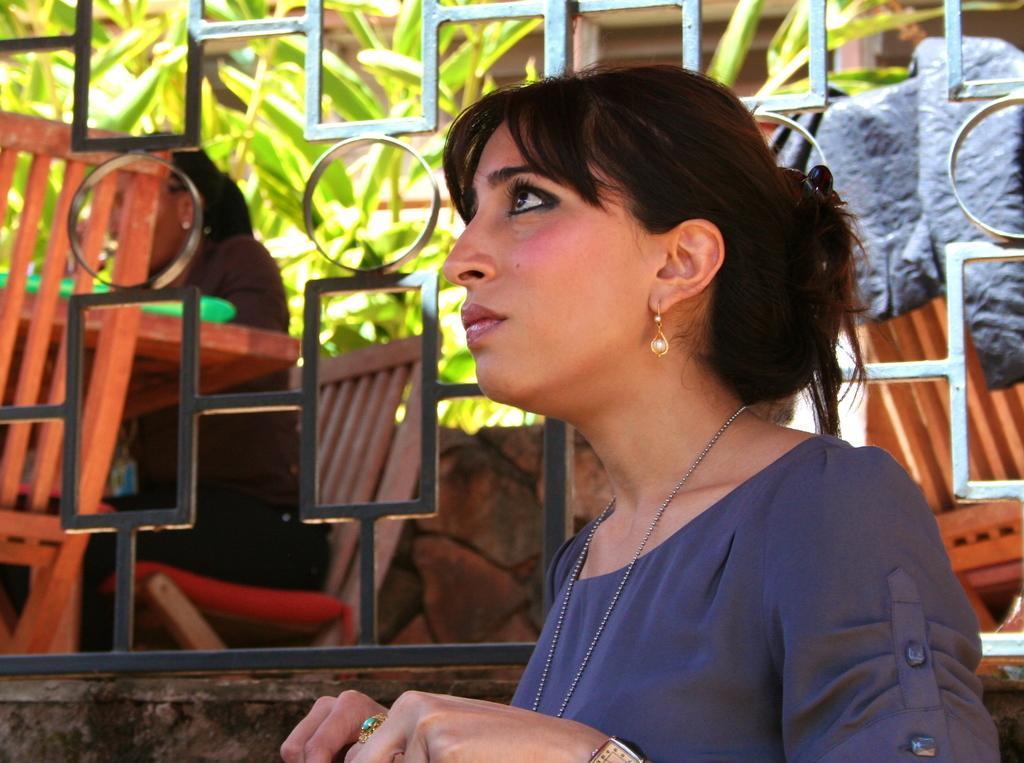Who is present in the image? There is a woman in the image. What is the woman doing in the image? The woman is staring at something behind her. What can be seen in the background of the image? There is an iron grill in the image. What type of mask is the writer wearing in the image? There is no writer or mask present in the image; it features a woman staring at something behind her and an iron grill in the background. 